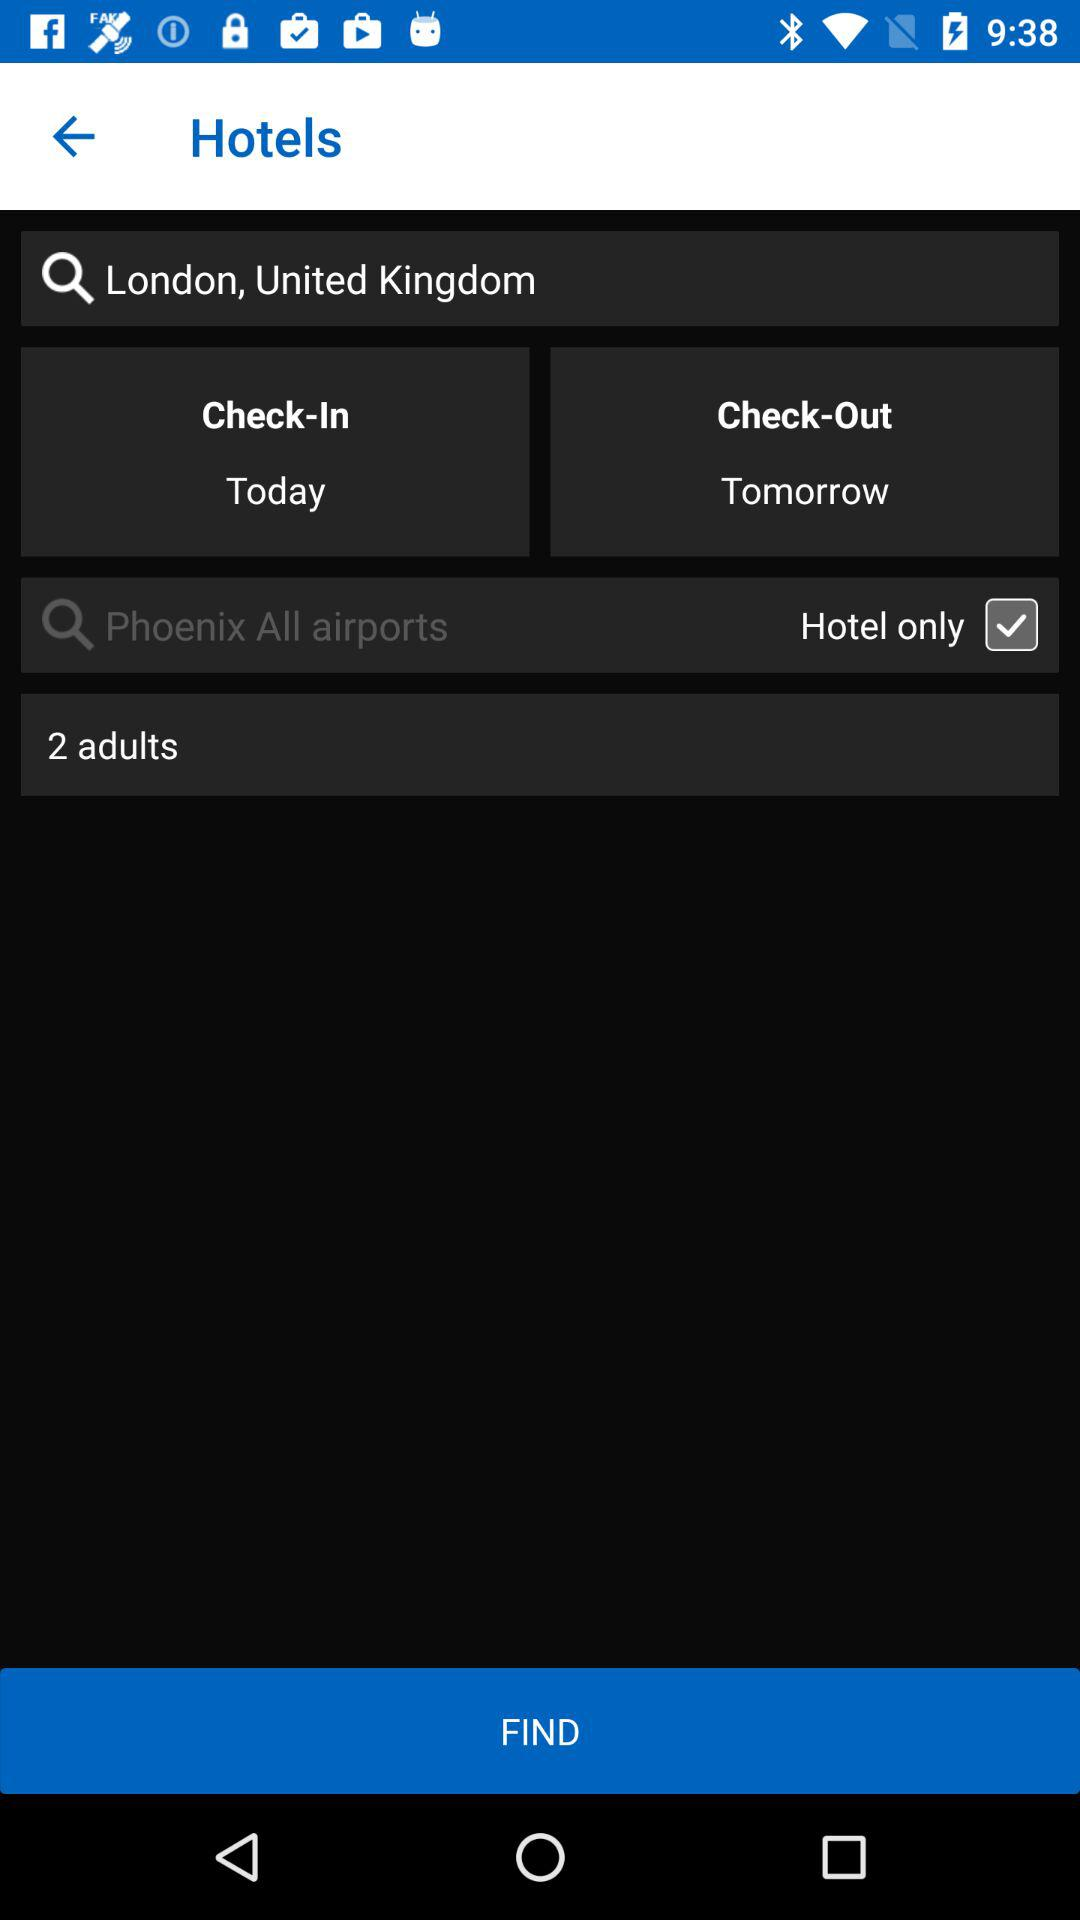How many adults are there? There are 2 adults. 